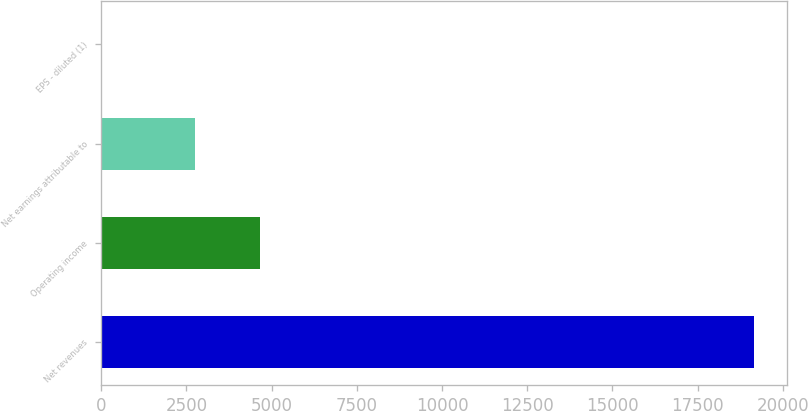Convert chart. <chart><loc_0><loc_0><loc_500><loc_500><bar_chart><fcel>Net revenues<fcel>Operating income<fcel>Net earnings attributable to<fcel>EPS - diluted (1)<nl><fcel>19162.7<fcel>4673.49<fcel>2757.4<fcel>1.82<nl></chart> 